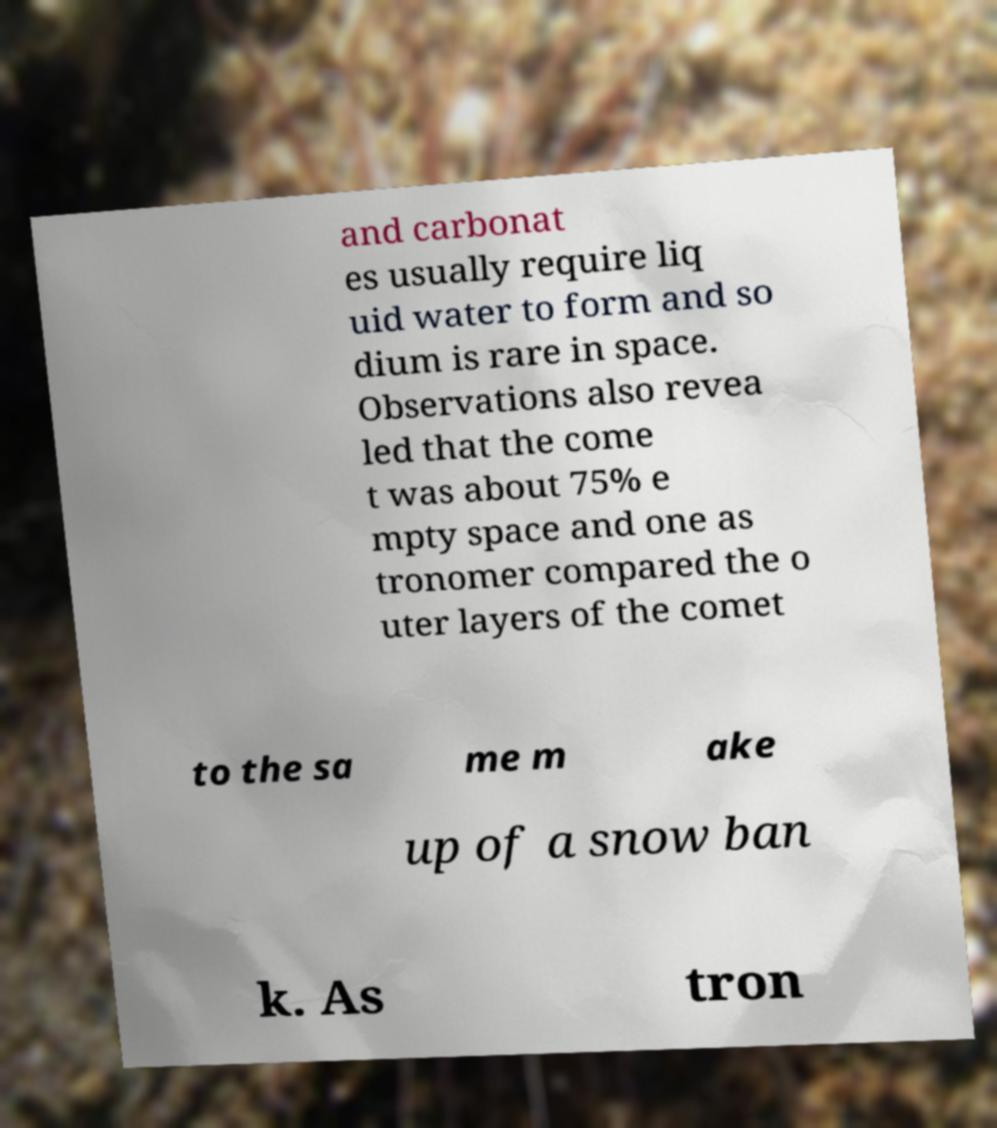Please read and relay the text visible in this image. What does it say? and carbonat es usually require liq uid water to form and so dium is rare in space. Observations also revea led that the come t was about 75% e mpty space and one as tronomer compared the o uter layers of the comet to the sa me m ake up of a snow ban k. As tron 